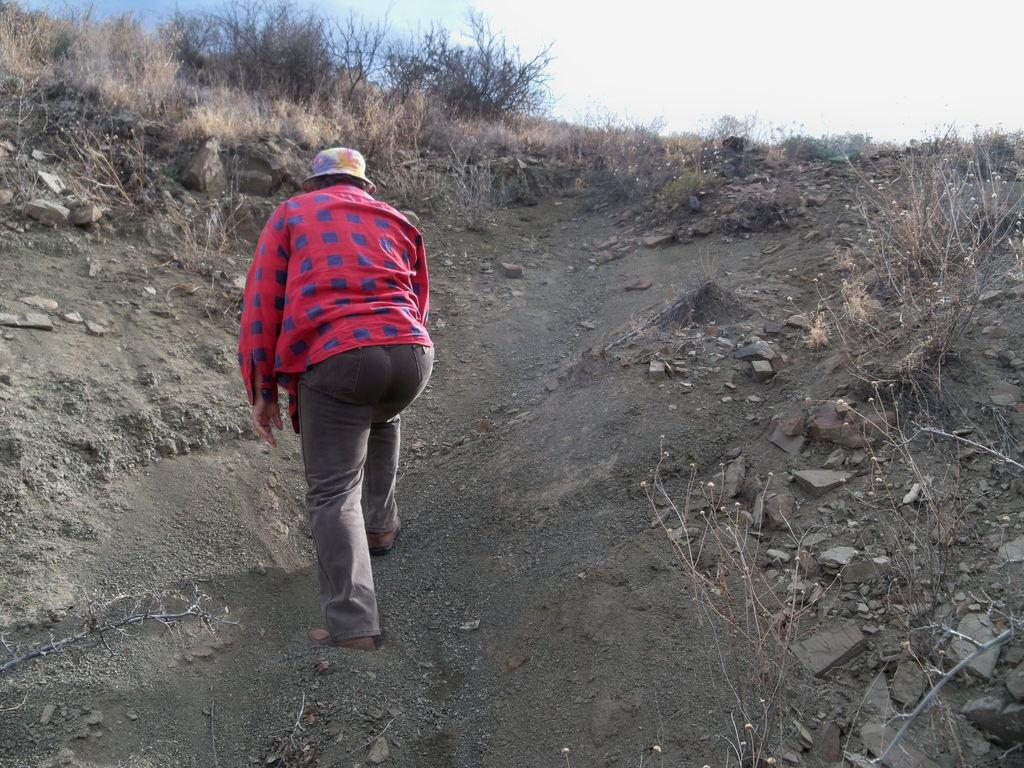What type of terrain is depicted in the image? There is a hill in the image. What materials make up the hill? The hill has mud and stone. What type of vegetation is present on the hill? There is dried grass on the hill. What is visible in the background of the image? The sky is visible in the image. What is the condition of the sky in the image? There are clouds in the sky. How much profit can be made from the apples growing on the hill in the image? There are no apples present in the image, so it is not possible to determine any potential profit. 